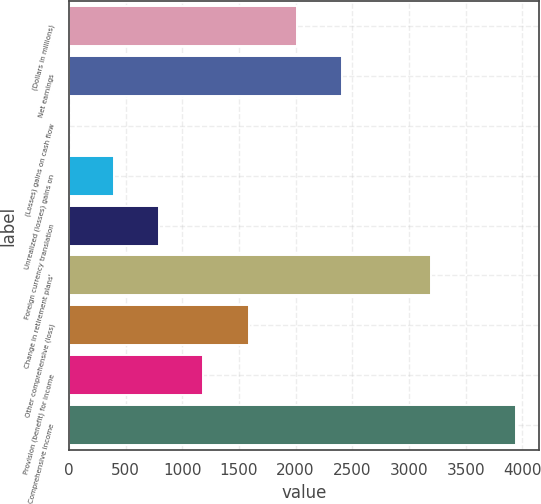Convert chart to OTSL. <chart><loc_0><loc_0><loc_500><loc_500><bar_chart><fcel>(Dollars in millions)<fcel>Net earnings<fcel>(Losses) gains on cash flow<fcel>Unrealized (losses) gains on<fcel>Foreign currency translation<fcel>Change in retirement plans'<fcel>Other comprehensive (loss)<fcel>Provision (benefit) for income<fcel>Comprehensive income<nl><fcel>2013<fcel>2407.4<fcel>3<fcel>397.4<fcel>791.8<fcel>3196.2<fcel>1590<fcel>1186.2<fcel>3947<nl></chart> 